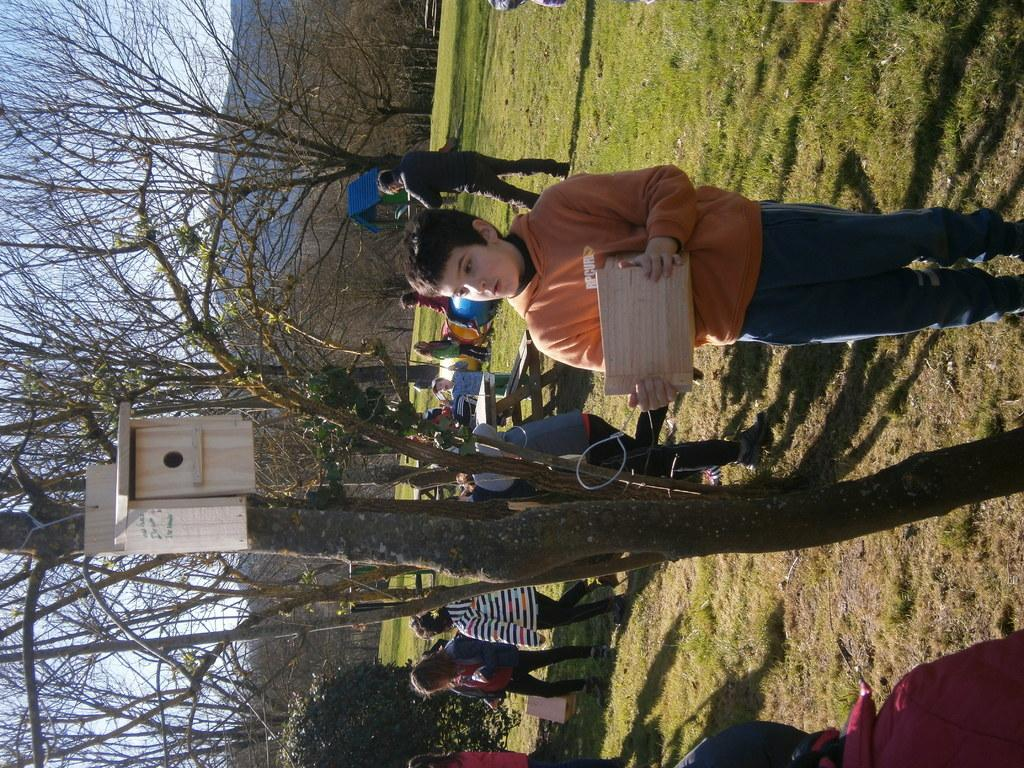What can be seen in the image? There is a group of people in the image. Can you describe the boy on the right side of the image? The boy is on the right side of the image and is holding a wooden plank. What is visible in the background of the image? There are trees and hills visible in the background of the image. What type of pet is the boy holding in the image? There is no pet visible in the image; the boy is holding a wooden plank. How many cars can be seen in the image? There are no cars present in the image. 